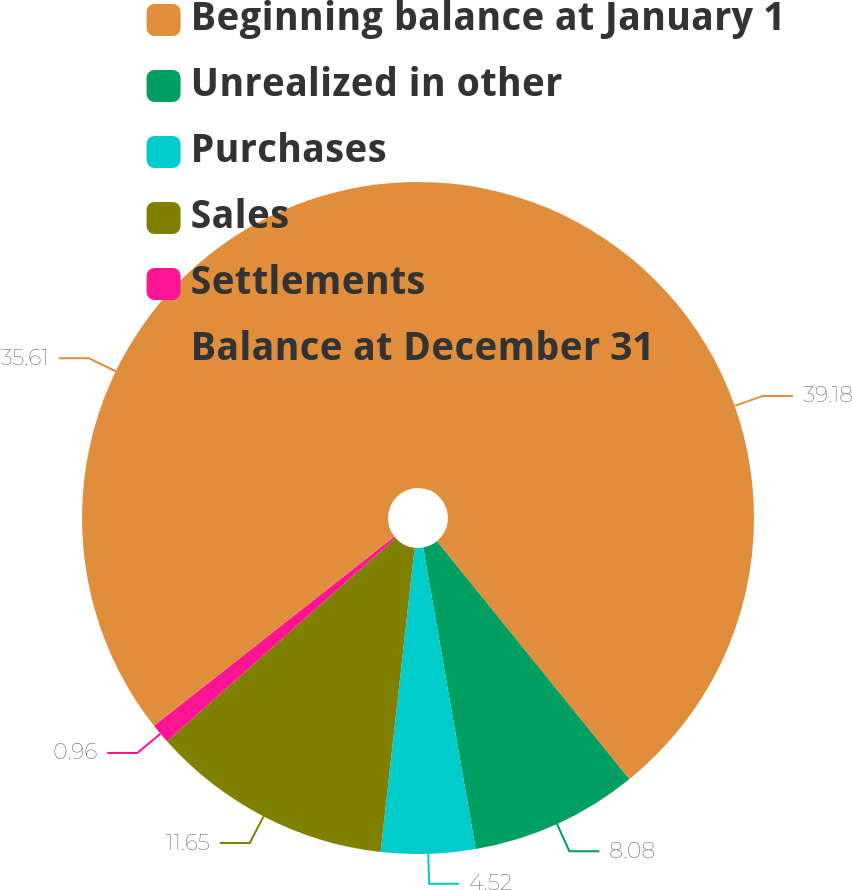Convert chart to OTSL. <chart><loc_0><loc_0><loc_500><loc_500><pie_chart><fcel>Beginning balance at January 1<fcel>Unrealized in other<fcel>Purchases<fcel>Sales<fcel>Settlements<fcel>Balance at December 31<nl><fcel>39.17%<fcel>8.08%<fcel>4.52%<fcel>11.65%<fcel>0.96%<fcel>35.61%<nl></chart> 